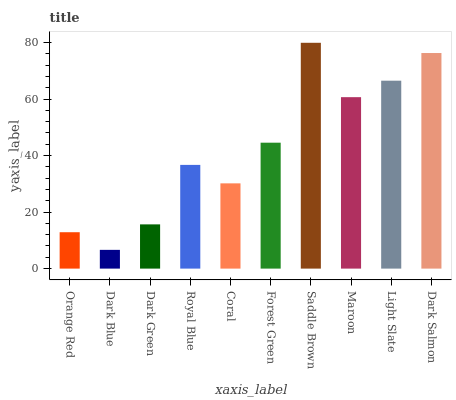Is Dark Blue the minimum?
Answer yes or no. Yes. Is Saddle Brown the maximum?
Answer yes or no. Yes. Is Dark Green the minimum?
Answer yes or no. No. Is Dark Green the maximum?
Answer yes or no. No. Is Dark Green greater than Dark Blue?
Answer yes or no. Yes. Is Dark Blue less than Dark Green?
Answer yes or no. Yes. Is Dark Blue greater than Dark Green?
Answer yes or no. No. Is Dark Green less than Dark Blue?
Answer yes or no. No. Is Forest Green the high median?
Answer yes or no. Yes. Is Royal Blue the low median?
Answer yes or no. Yes. Is Coral the high median?
Answer yes or no. No. Is Dark Green the low median?
Answer yes or no. No. 